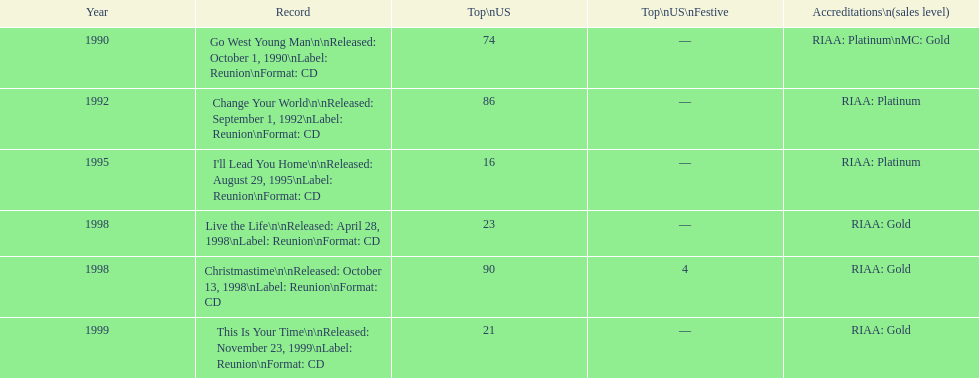How many albums by michael w. smith reached the top 25 in the charts? 3. 